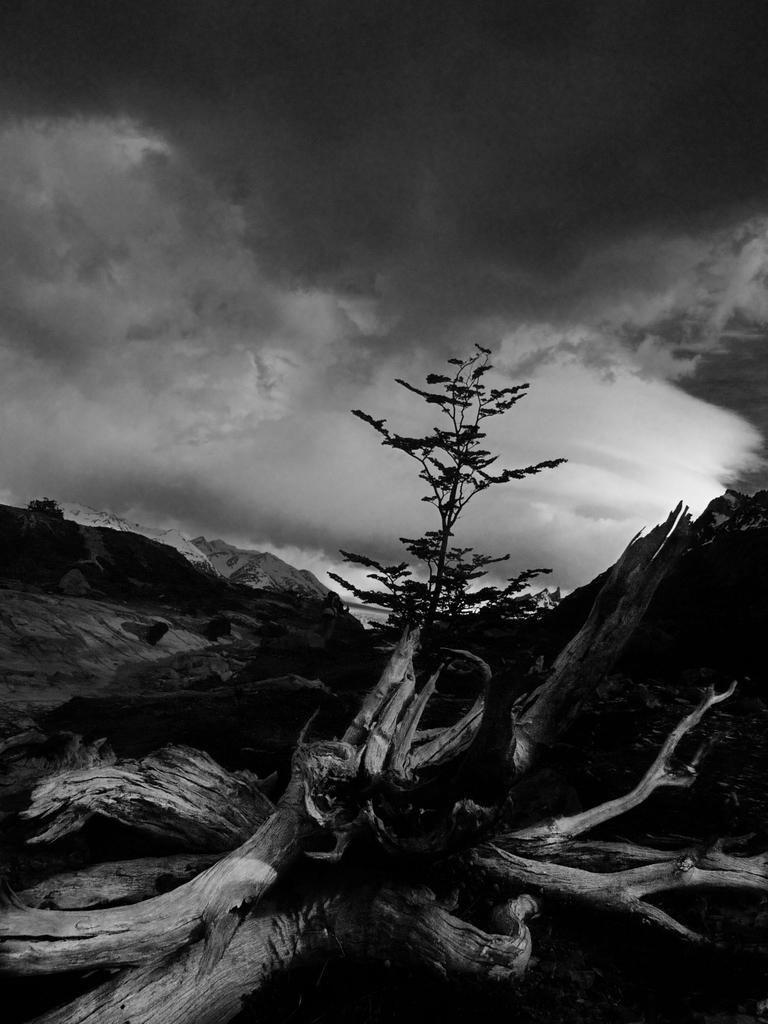What is the color scheme of the image? The image is black and white. What part of the natural environment is visible in the image? There is a sky visible in the image. What can be seen in the sky? Clouds are present in the sky. What type of vegetation is visible in the image? There are trees in the image. What type of geographical feature is present in the image? There are hills in the image. What type of living organisms can be seen in the image? Plants are present in the image. Can you tell me how many pets are visible in the image? There are no pets present in the image. What type of wave can be seen crashing against the shore in the image? There is no shore or wave present in the image. 